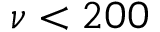<formula> <loc_0><loc_0><loc_500><loc_500>\nu < 2 0 0</formula> 